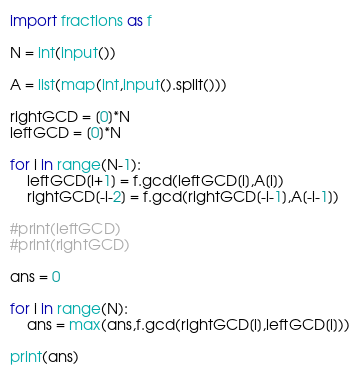<code> <loc_0><loc_0><loc_500><loc_500><_Python_>import fractions as f

N = int(input())

A = list(map(int,input().split()))

rightGCD = [0]*N
leftGCD = [0]*N

for i in range(N-1):
    leftGCD[i+1] = f.gcd(leftGCD[i],A[i])
    rightGCD[-i-2] = f.gcd(rightGCD[-i-1],A[-i-1])

#print(leftGCD)
#print(rightGCD)

ans = 0

for i in range(N):
    ans = max(ans,f.gcd(rightGCD[i],leftGCD[i]))

print(ans)
</code> 